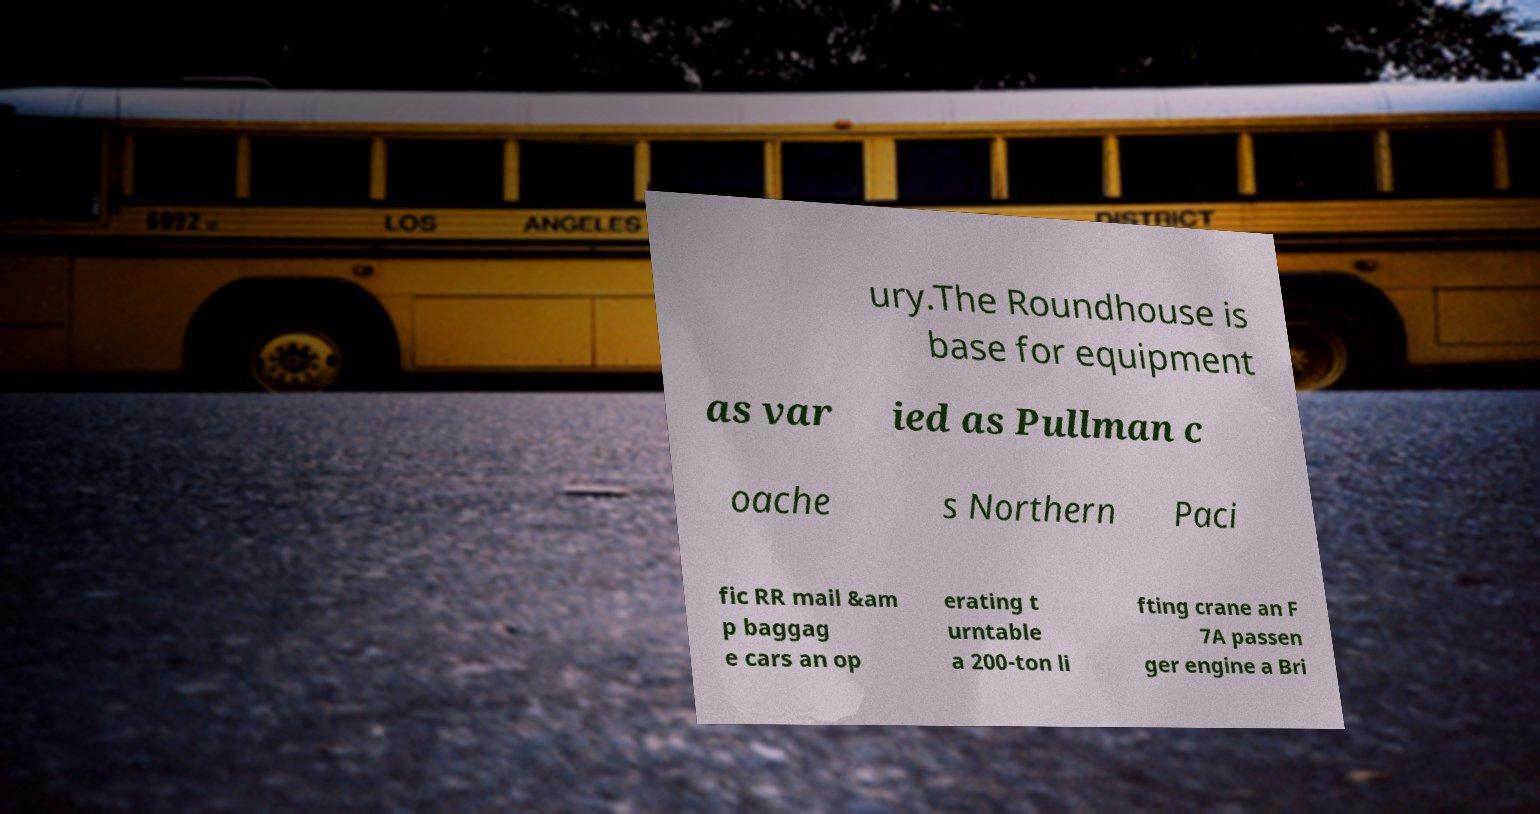I need the written content from this picture converted into text. Can you do that? ury.The Roundhouse is base for equipment as var ied as Pullman c oache s Northern Paci fic RR mail &am p baggag e cars an op erating t urntable a 200-ton li fting crane an F 7A passen ger engine a Bri 